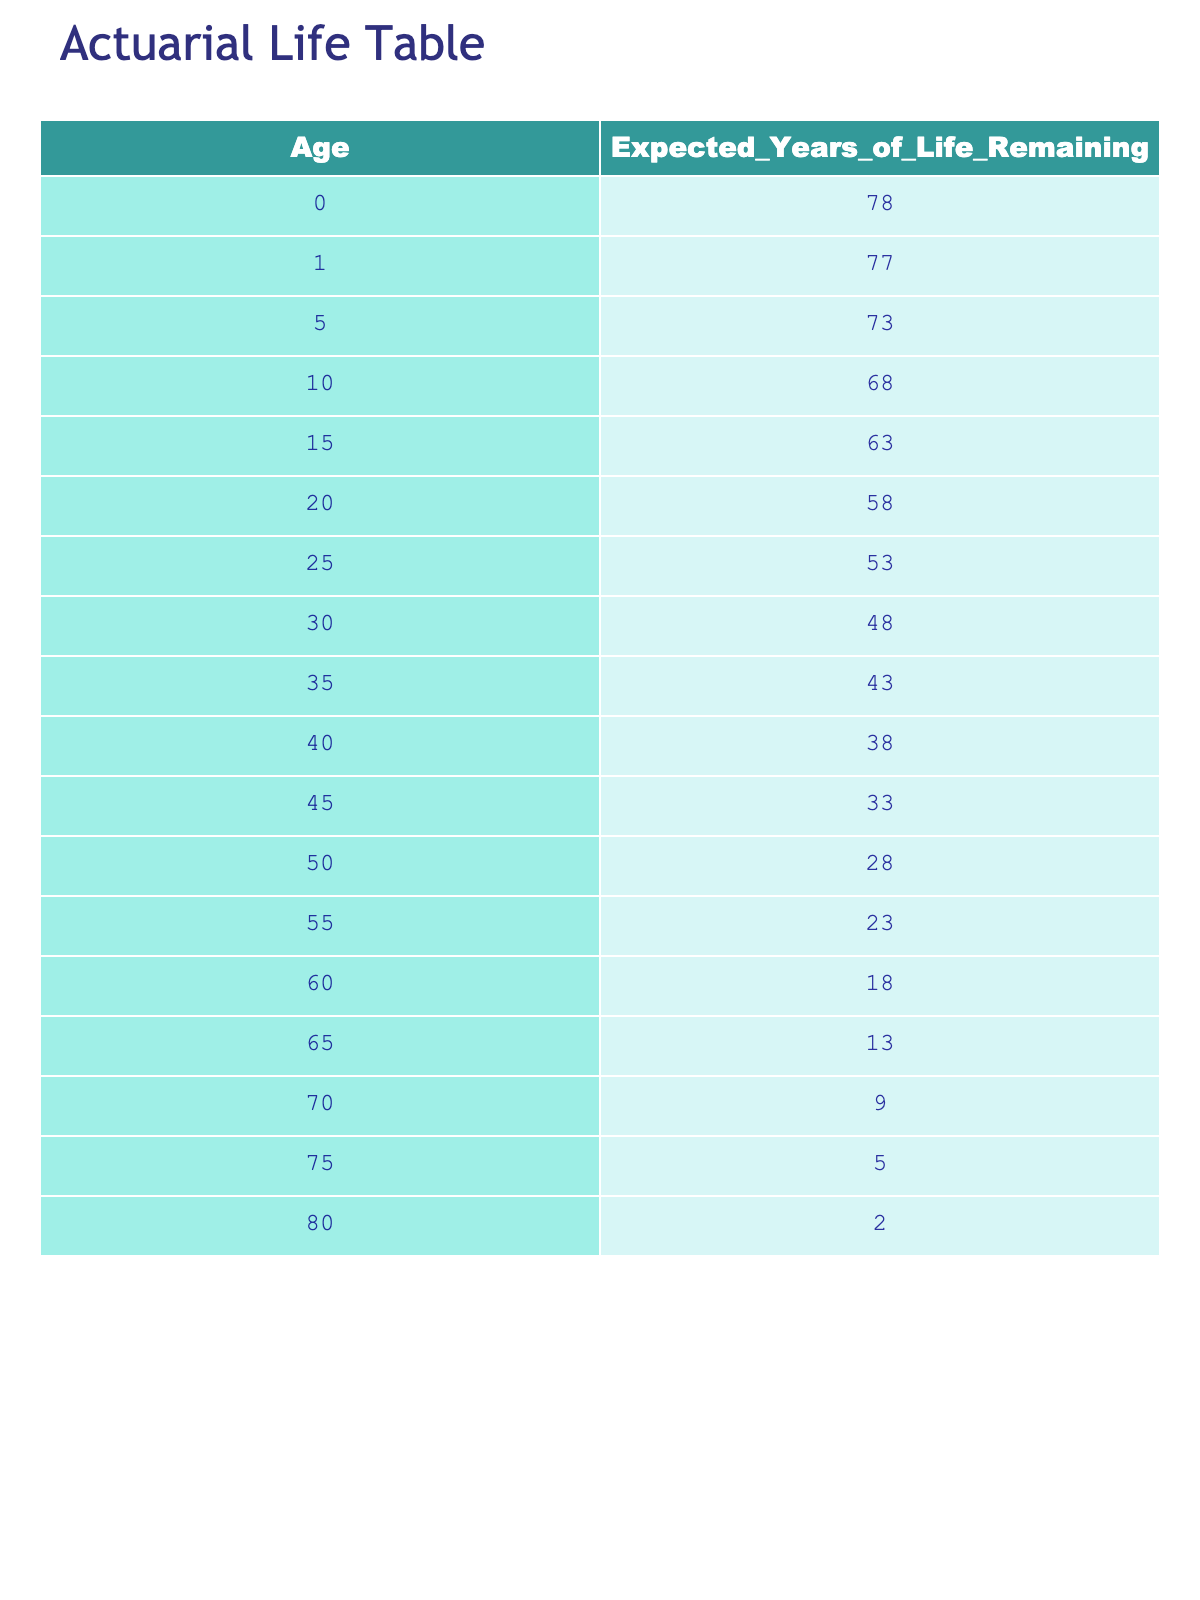What is the expected years of life remaining for a 30-year-old? Looking at the table, the row for age 30 shows that the expected years of life remaining is 48.
Answer: 48 What is the expected years of life remaining for a newborn? The row for age 0 indicates that the expected years of life remaining is 78.
Answer: 78 Which age has the lowest expected years of life remaining? The row for age 80 shows the lowest expected years of life remaining at 2.
Answer: 2 Is it true that a 65-year-old has more expected years of life remaining than a 70-year-old? For age 65, the expected years of life remaining is 13, and for age 70, it is 9. Since 13 is greater than 9, the statement is true.
Answer: Yes Calculate the total expected years of life remaining for individuals aged 0 to 15. The expected years of life remaining for ages 0, 1, 5, 10, and 15 are 78, 77, 73, 68, and 63 respectively. Adding these values: 78 + 77 + 73 + 68 + 63 = 359.
Answer: 359 What is the average expected years of life remaining for individuals aged 50 and older? The ages 50, 55, 60, 65, 70, 75, and 80 have expected years of life remaining of 28, 23, 18, 13, 9, 5, and 2. Adding these values gives 28 + 23 + 18 + 13 + 9 + 5 + 2 = 98. There are 7 data points, so the average is 98/7 ≈ 14.
Answer: 14 Is the expected years of life remaining decreasing consistently as age increases? By analyzing the table, we see that the expected years of life remaining decreases with each age increase. Each consecutive age has fewer years of life remaining, confirming the trend of decreasing values.
Answer: Yes What is the difference in expected years of life remaining between a 60-year-old and a 50-year-old? The expected years of life remaining for a 60-year-old is 18 and for a 50-year-old is 28. To find the difference: 28 - 18 = 10.
Answer: 10 Which age has an expected years of life remaining value that is 10 years less than the previous age? Comparing ages, age 50 has 28 years and age 55 has 23 years. The difference is 28 - 23 = 5, which is not 10. However, age 60 has 18 years and age 55 has 23 years, so this is not a match either. The row for age 70 shows 9 years, which is not a match. It turns out that the only discrepancy of a drop of exactly 10 years occurs between ages 75 (5 years) and age 80 (2 years).
Answer: Age 80 